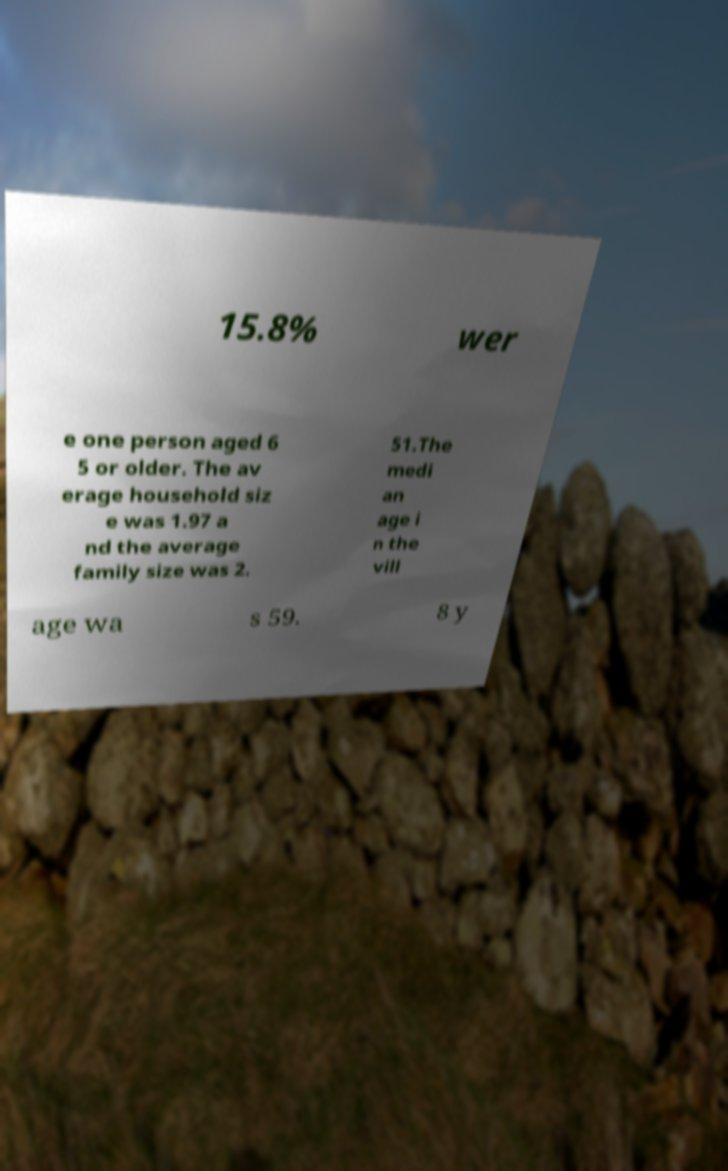Please read and relay the text visible in this image. What does it say? 15.8% wer e one person aged 6 5 or older. The av erage household siz e was 1.97 a nd the average family size was 2. 51.The medi an age i n the vill age wa s 59. 8 y 